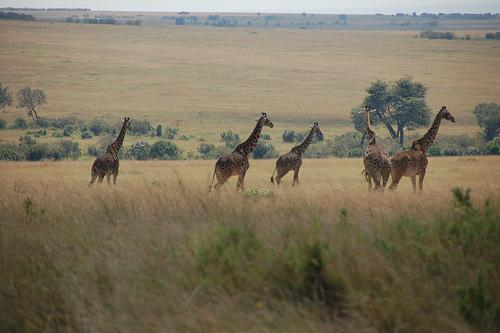In the context of the image, come up with a marketing slogan for a wildlife conservation campaign. "Protect their home, preserve their beauty: Join the efforts to conserve giraffes and their habitats." Point out the main elements of the image. There are several giraffes wandering in a grassy plain, with some zebras and trees in the background, and a dark tuft of grass close to the camera. What is the primary focus of this picture? The primary focus is a group of giraffes wandering the plain among a wide green field. In a few words, describe the setting of the image. The setting is a wide, green field with giraffes wandering, and some trees in the background. Create a title for an article about this image. "Harmony in the Wild: Giraffes and Zebras Wander a Grassy Plain Together in Nature's Masterpiece" Using the available information, describe the scene as if you are a wildlife tour guide. Welcome to the African savanna, where you can observe several majestic giraffes and zebras roaming the lush green fields, while taking in the beauty of the diverse flora and fauna that call this place home. Identify the two distinct animal species present in the image. The image contains giraffes and zebras. 